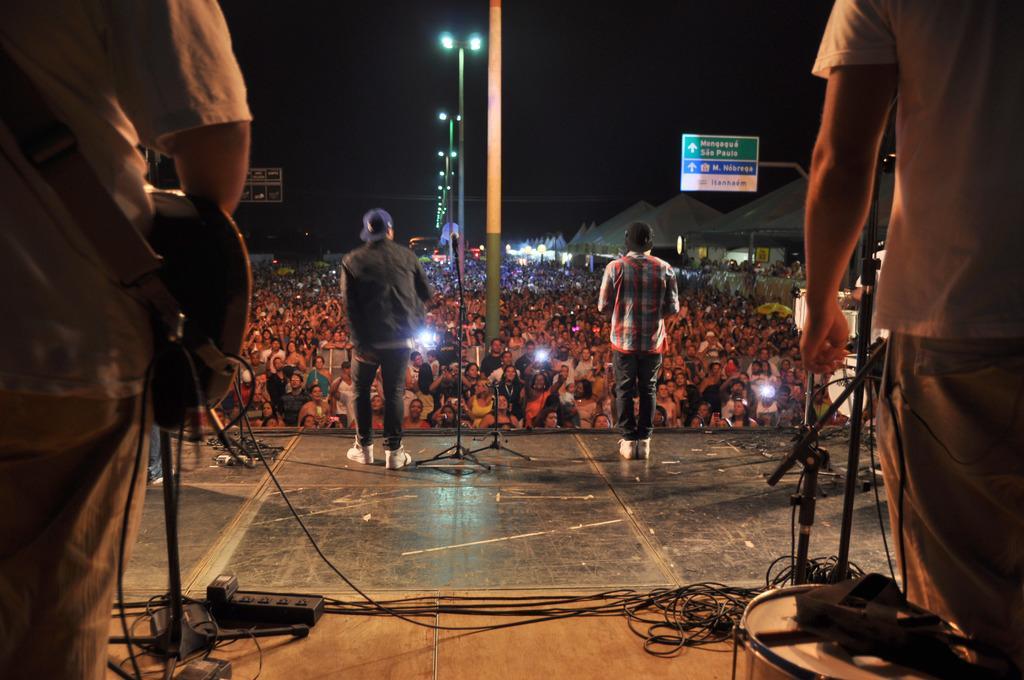In one or two sentences, can you explain what this image depicts? There are four persons standing on stage and there are audience in front of them. 